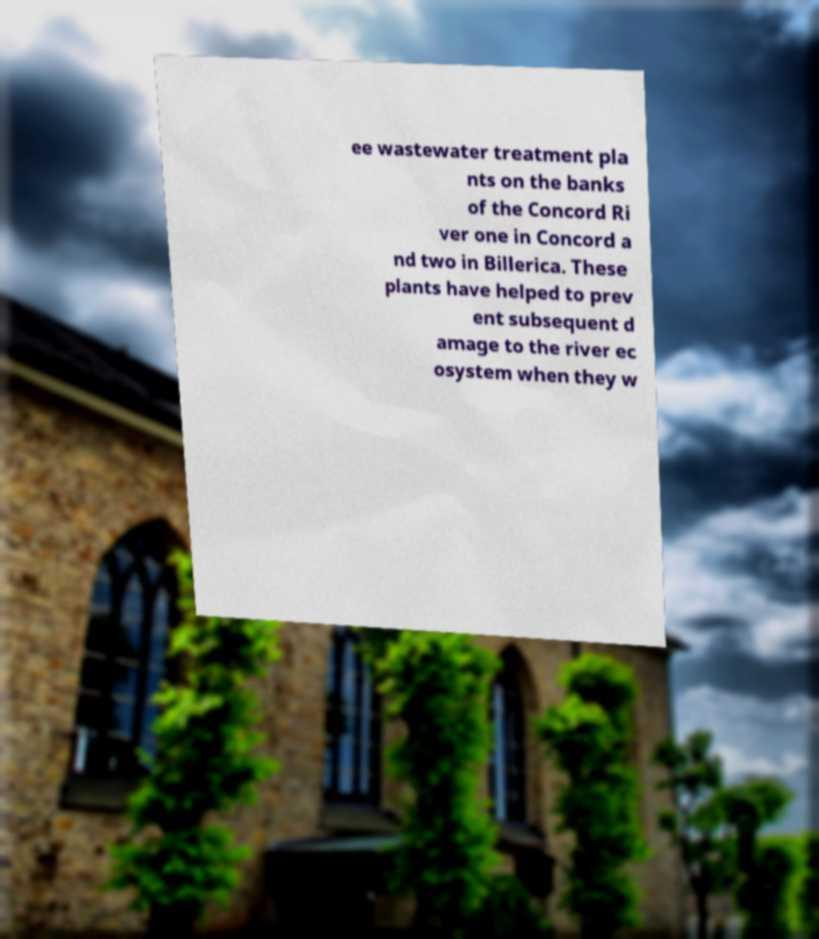Could you assist in decoding the text presented in this image and type it out clearly? ee wastewater treatment pla nts on the banks of the Concord Ri ver one in Concord a nd two in Billerica. These plants have helped to prev ent subsequent d amage to the river ec osystem when they w 